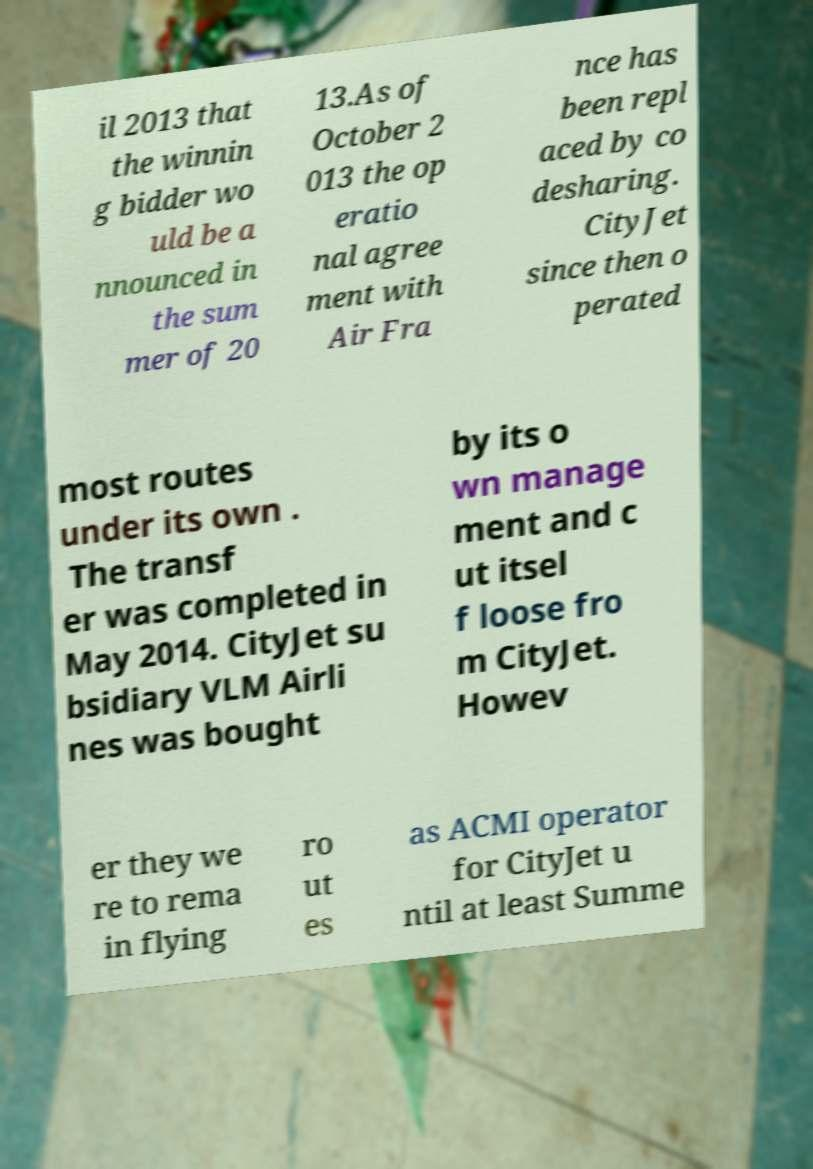Could you assist in decoding the text presented in this image and type it out clearly? il 2013 that the winnin g bidder wo uld be a nnounced in the sum mer of 20 13.As of October 2 013 the op eratio nal agree ment with Air Fra nce has been repl aced by co desharing. CityJet since then o perated most routes under its own . The transf er was completed in May 2014. CityJet su bsidiary VLM Airli nes was bought by its o wn manage ment and c ut itsel f loose fro m CityJet. Howev er they we re to rema in flying ro ut es as ACMI operator for CityJet u ntil at least Summe 